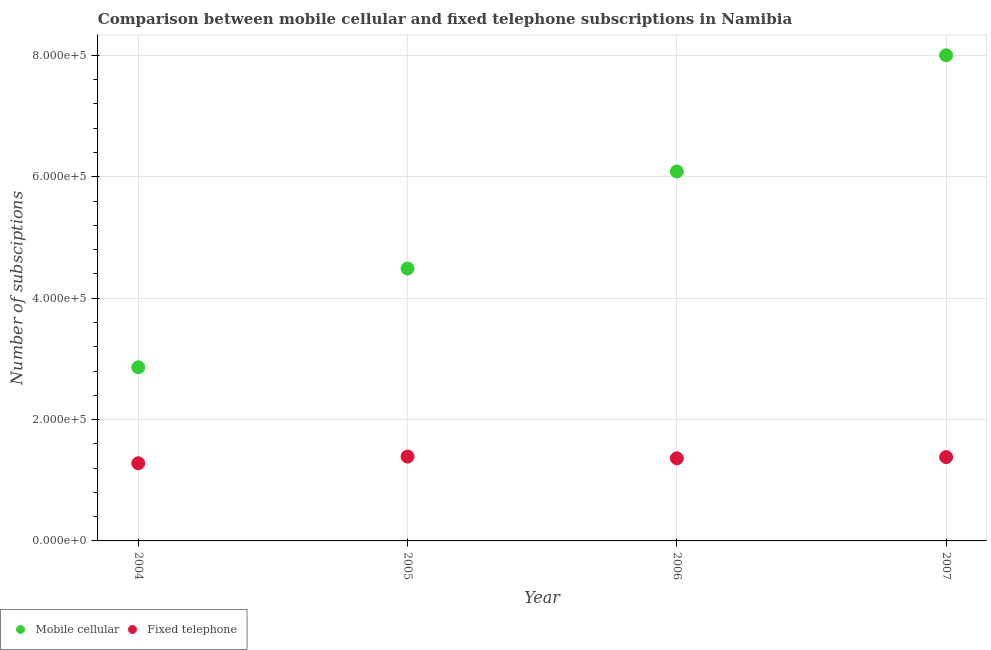How many different coloured dotlines are there?
Your answer should be compact. 2. Is the number of dotlines equal to the number of legend labels?
Your answer should be very brief. Yes. What is the number of fixed telephone subscriptions in 2004?
Keep it short and to the point. 1.28e+05. Across all years, what is the maximum number of mobile cellular subscriptions?
Give a very brief answer. 8.00e+05. Across all years, what is the minimum number of fixed telephone subscriptions?
Your answer should be very brief. 1.28e+05. What is the total number of fixed telephone subscriptions in the graph?
Keep it short and to the point. 5.41e+05. What is the difference between the number of fixed telephone subscriptions in 2005 and that in 2006?
Offer a terse response. 2834. What is the difference between the number of fixed telephone subscriptions in 2005 and the number of mobile cellular subscriptions in 2004?
Ensure brevity in your answer.  -1.47e+05. What is the average number of mobile cellular subscriptions per year?
Give a very brief answer. 5.36e+05. In the year 2005, what is the difference between the number of fixed telephone subscriptions and number of mobile cellular subscriptions?
Provide a succinct answer. -3.10e+05. What is the ratio of the number of fixed telephone subscriptions in 2004 to that in 2006?
Ensure brevity in your answer.  0.94. Is the number of mobile cellular subscriptions in 2005 less than that in 2006?
Keep it short and to the point. Yes. Is the difference between the number of mobile cellular subscriptions in 2005 and 2007 greater than the difference between the number of fixed telephone subscriptions in 2005 and 2007?
Provide a succinct answer. No. What is the difference between the highest and the second highest number of fixed telephone subscriptions?
Provide a succinct answer. 826. What is the difference between the highest and the lowest number of fixed telephone subscriptions?
Your answer should be compact. 1.11e+04. In how many years, is the number of fixed telephone subscriptions greater than the average number of fixed telephone subscriptions taken over all years?
Ensure brevity in your answer.  3. Is the sum of the number of mobile cellular subscriptions in 2004 and 2006 greater than the maximum number of fixed telephone subscriptions across all years?
Ensure brevity in your answer.  Yes. Does the number of fixed telephone subscriptions monotonically increase over the years?
Give a very brief answer. No. Are the values on the major ticks of Y-axis written in scientific E-notation?
Your answer should be compact. Yes. Does the graph contain grids?
Make the answer very short. Yes. Where does the legend appear in the graph?
Your response must be concise. Bottom left. How many legend labels are there?
Ensure brevity in your answer.  2. What is the title of the graph?
Offer a terse response. Comparison between mobile cellular and fixed telephone subscriptions in Namibia. What is the label or title of the Y-axis?
Provide a succinct answer. Number of subsciptions. What is the Number of subsciptions in Mobile cellular in 2004?
Ensure brevity in your answer.  2.86e+05. What is the Number of subsciptions of Fixed telephone in 2004?
Offer a very short reply. 1.28e+05. What is the Number of subsciptions in Mobile cellular in 2005?
Ensure brevity in your answer.  4.49e+05. What is the Number of subsciptions of Fixed telephone in 2005?
Your answer should be very brief. 1.39e+05. What is the Number of subsciptions of Mobile cellular in 2006?
Offer a terse response. 6.09e+05. What is the Number of subsciptions in Fixed telephone in 2006?
Provide a short and direct response. 1.36e+05. What is the Number of subsciptions of Mobile cellular in 2007?
Keep it short and to the point. 8.00e+05. What is the Number of subsciptions in Fixed telephone in 2007?
Your answer should be compact. 1.38e+05. Across all years, what is the maximum Number of subsciptions in Mobile cellular?
Offer a terse response. 8.00e+05. Across all years, what is the maximum Number of subsciptions of Fixed telephone?
Provide a short and direct response. 1.39e+05. Across all years, what is the minimum Number of subsciptions in Mobile cellular?
Your answer should be compact. 2.86e+05. Across all years, what is the minimum Number of subsciptions in Fixed telephone?
Make the answer very short. 1.28e+05. What is the total Number of subsciptions of Mobile cellular in the graph?
Offer a very short reply. 2.14e+06. What is the total Number of subsciptions in Fixed telephone in the graph?
Make the answer very short. 5.41e+05. What is the difference between the Number of subsciptions of Mobile cellular in 2004 and that in 2005?
Give a very brief answer. -1.63e+05. What is the difference between the Number of subsciptions in Fixed telephone in 2004 and that in 2005?
Offer a terse response. -1.11e+04. What is the difference between the Number of subsciptions of Mobile cellular in 2004 and that in 2006?
Provide a short and direct response. -3.23e+05. What is the difference between the Number of subsciptions in Fixed telephone in 2004 and that in 2006?
Ensure brevity in your answer.  -8228. What is the difference between the Number of subsciptions in Mobile cellular in 2004 and that in 2007?
Make the answer very short. -5.14e+05. What is the difference between the Number of subsciptions in Fixed telephone in 2004 and that in 2007?
Offer a terse response. -1.02e+04. What is the difference between the Number of subsciptions in Mobile cellular in 2005 and that in 2006?
Offer a very short reply. -1.60e+05. What is the difference between the Number of subsciptions of Fixed telephone in 2005 and that in 2006?
Offer a terse response. 2834. What is the difference between the Number of subsciptions in Mobile cellular in 2005 and that in 2007?
Provide a short and direct response. -3.51e+05. What is the difference between the Number of subsciptions of Fixed telephone in 2005 and that in 2007?
Provide a succinct answer. 826. What is the difference between the Number of subsciptions in Mobile cellular in 2006 and that in 2007?
Offer a terse response. -1.91e+05. What is the difference between the Number of subsciptions in Fixed telephone in 2006 and that in 2007?
Offer a very short reply. -2008. What is the difference between the Number of subsciptions in Mobile cellular in 2004 and the Number of subsciptions in Fixed telephone in 2005?
Make the answer very short. 1.47e+05. What is the difference between the Number of subsciptions in Mobile cellular in 2004 and the Number of subsciptions in Fixed telephone in 2006?
Your answer should be very brief. 1.50e+05. What is the difference between the Number of subsciptions of Mobile cellular in 2004 and the Number of subsciptions of Fixed telephone in 2007?
Your answer should be very brief. 1.48e+05. What is the difference between the Number of subsciptions of Mobile cellular in 2005 and the Number of subsciptions of Fixed telephone in 2006?
Ensure brevity in your answer.  3.13e+05. What is the difference between the Number of subsciptions in Mobile cellular in 2005 and the Number of subsciptions in Fixed telephone in 2007?
Provide a short and direct response. 3.11e+05. What is the difference between the Number of subsciptions of Mobile cellular in 2006 and the Number of subsciptions of Fixed telephone in 2007?
Your response must be concise. 4.71e+05. What is the average Number of subsciptions of Mobile cellular per year?
Your answer should be very brief. 5.36e+05. What is the average Number of subsciptions of Fixed telephone per year?
Provide a short and direct response. 1.35e+05. In the year 2004, what is the difference between the Number of subsciptions of Mobile cellular and Number of subsciptions of Fixed telephone?
Offer a very short reply. 1.58e+05. In the year 2005, what is the difference between the Number of subsciptions in Mobile cellular and Number of subsciptions in Fixed telephone?
Give a very brief answer. 3.10e+05. In the year 2006, what is the difference between the Number of subsciptions of Mobile cellular and Number of subsciptions of Fixed telephone?
Make the answer very short. 4.73e+05. In the year 2007, what is the difference between the Number of subsciptions in Mobile cellular and Number of subsciptions in Fixed telephone?
Provide a succinct answer. 6.62e+05. What is the ratio of the Number of subsciptions of Mobile cellular in 2004 to that in 2005?
Your response must be concise. 0.64. What is the ratio of the Number of subsciptions of Fixed telephone in 2004 to that in 2005?
Your response must be concise. 0.92. What is the ratio of the Number of subsciptions of Mobile cellular in 2004 to that in 2006?
Make the answer very short. 0.47. What is the ratio of the Number of subsciptions of Fixed telephone in 2004 to that in 2006?
Keep it short and to the point. 0.94. What is the ratio of the Number of subsciptions of Mobile cellular in 2004 to that in 2007?
Keep it short and to the point. 0.36. What is the ratio of the Number of subsciptions in Fixed telephone in 2004 to that in 2007?
Give a very brief answer. 0.93. What is the ratio of the Number of subsciptions in Mobile cellular in 2005 to that in 2006?
Make the answer very short. 0.74. What is the ratio of the Number of subsciptions in Fixed telephone in 2005 to that in 2006?
Ensure brevity in your answer.  1.02. What is the ratio of the Number of subsciptions of Mobile cellular in 2005 to that in 2007?
Offer a very short reply. 0.56. What is the ratio of the Number of subsciptions of Fixed telephone in 2005 to that in 2007?
Provide a succinct answer. 1.01. What is the ratio of the Number of subsciptions of Mobile cellular in 2006 to that in 2007?
Ensure brevity in your answer.  0.76. What is the ratio of the Number of subsciptions of Fixed telephone in 2006 to that in 2007?
Offer a terse response. 0.99. What is the difference between the highest and the second highest Number of subsciptions in Mobile cellular?
Ensure brevity in your answer.  1.91e+05. What is the difference between the highest and the second highest Number of subsciptions of Fixed telephone?
Make the answer very short. 826. What is the difference between the highest and the lowest Number of subsciptions in Mobile cellular?
Your answer should be compact. 5.14e+05. What is the difference between the highest and the lowest Number of subsciptions of Fixed telephone?
Give a very brief answer. 1.11e+04. 